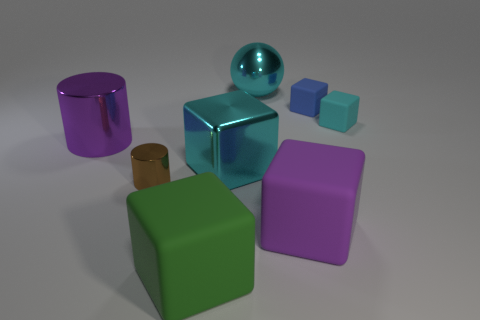Are there any objects that seem out of place in this collection? Considering the collection comprises various geometric shapes, all having a polished appearance, the wooden cylinder seems slightly out of place due to its matte texture and organic material, which contrasts with the other items' glossy, synthetic look. 